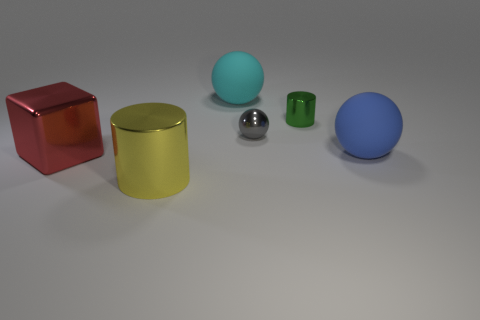How big is the matte sphere in front of the green object? The matte sphere located in front of the green cylindrical object has a diameter of approximately 5 centimeters. It is discernibly smaller than the blue sphere and significantly smaller than the gold and red objects in the scene. 